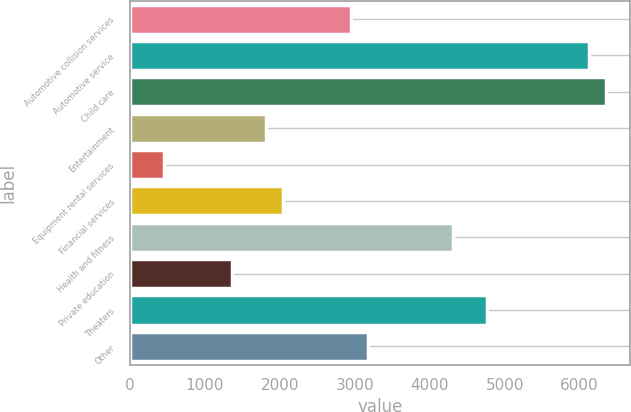Convert chart. <chart><loc_0><loc_0><loc_500><loc_500><bar_chart><fcel>Automotive collision services<fcel>Automotive service<fcel>Child care<fcel>Entertainment<fcel>Equipment rental services<fcel>Financial services<fcel>Health and fitness<fcel>Private education<fcel>Theaters<fcel>Other<nl><fcel>2950.7<fcel>6127.3<fcel>6354.2<fcel>1816.2<fcel>454.8<fcel>2043.1<fcel>4312.1<fcel>1362.4<fcel>4765.9<fcel>3177.6<nl></chart> 